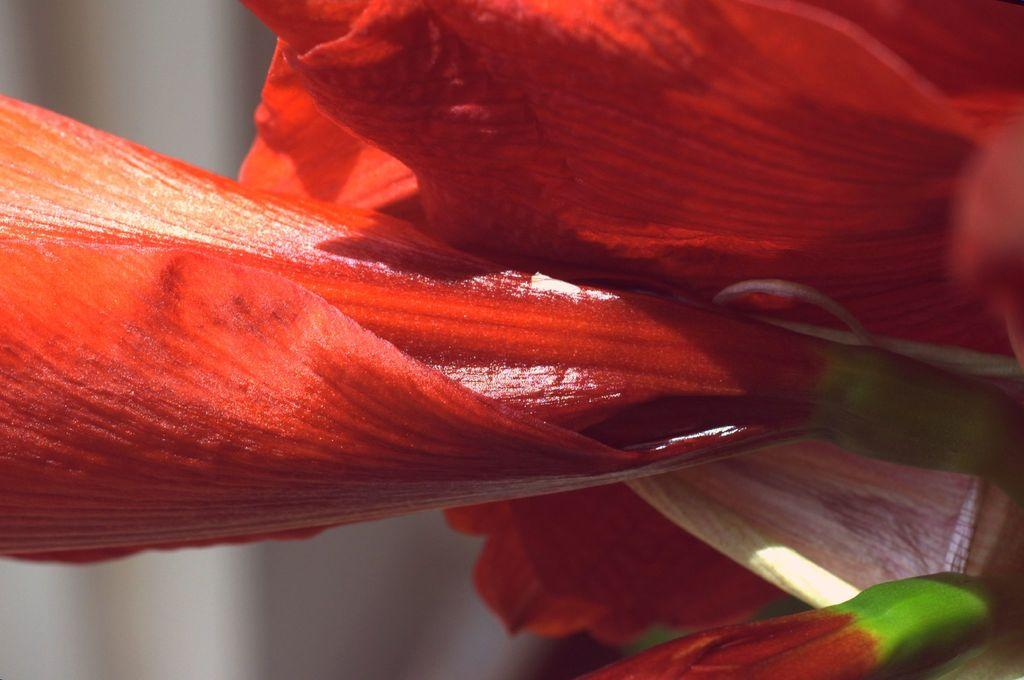What is the main subject of the image? There is a flower in the image. Can you describe the colors of the flower? The flower has red, cream, and green colors. How would you describe the background of the image? The background of the image is blurred. How many fingers can be seen touching the flower in the image? There are no fingers touching the flower in the image. What type of coil is wrapped around the stem of the flower in the image? There is no coil present around the stem of the flower in the image. 